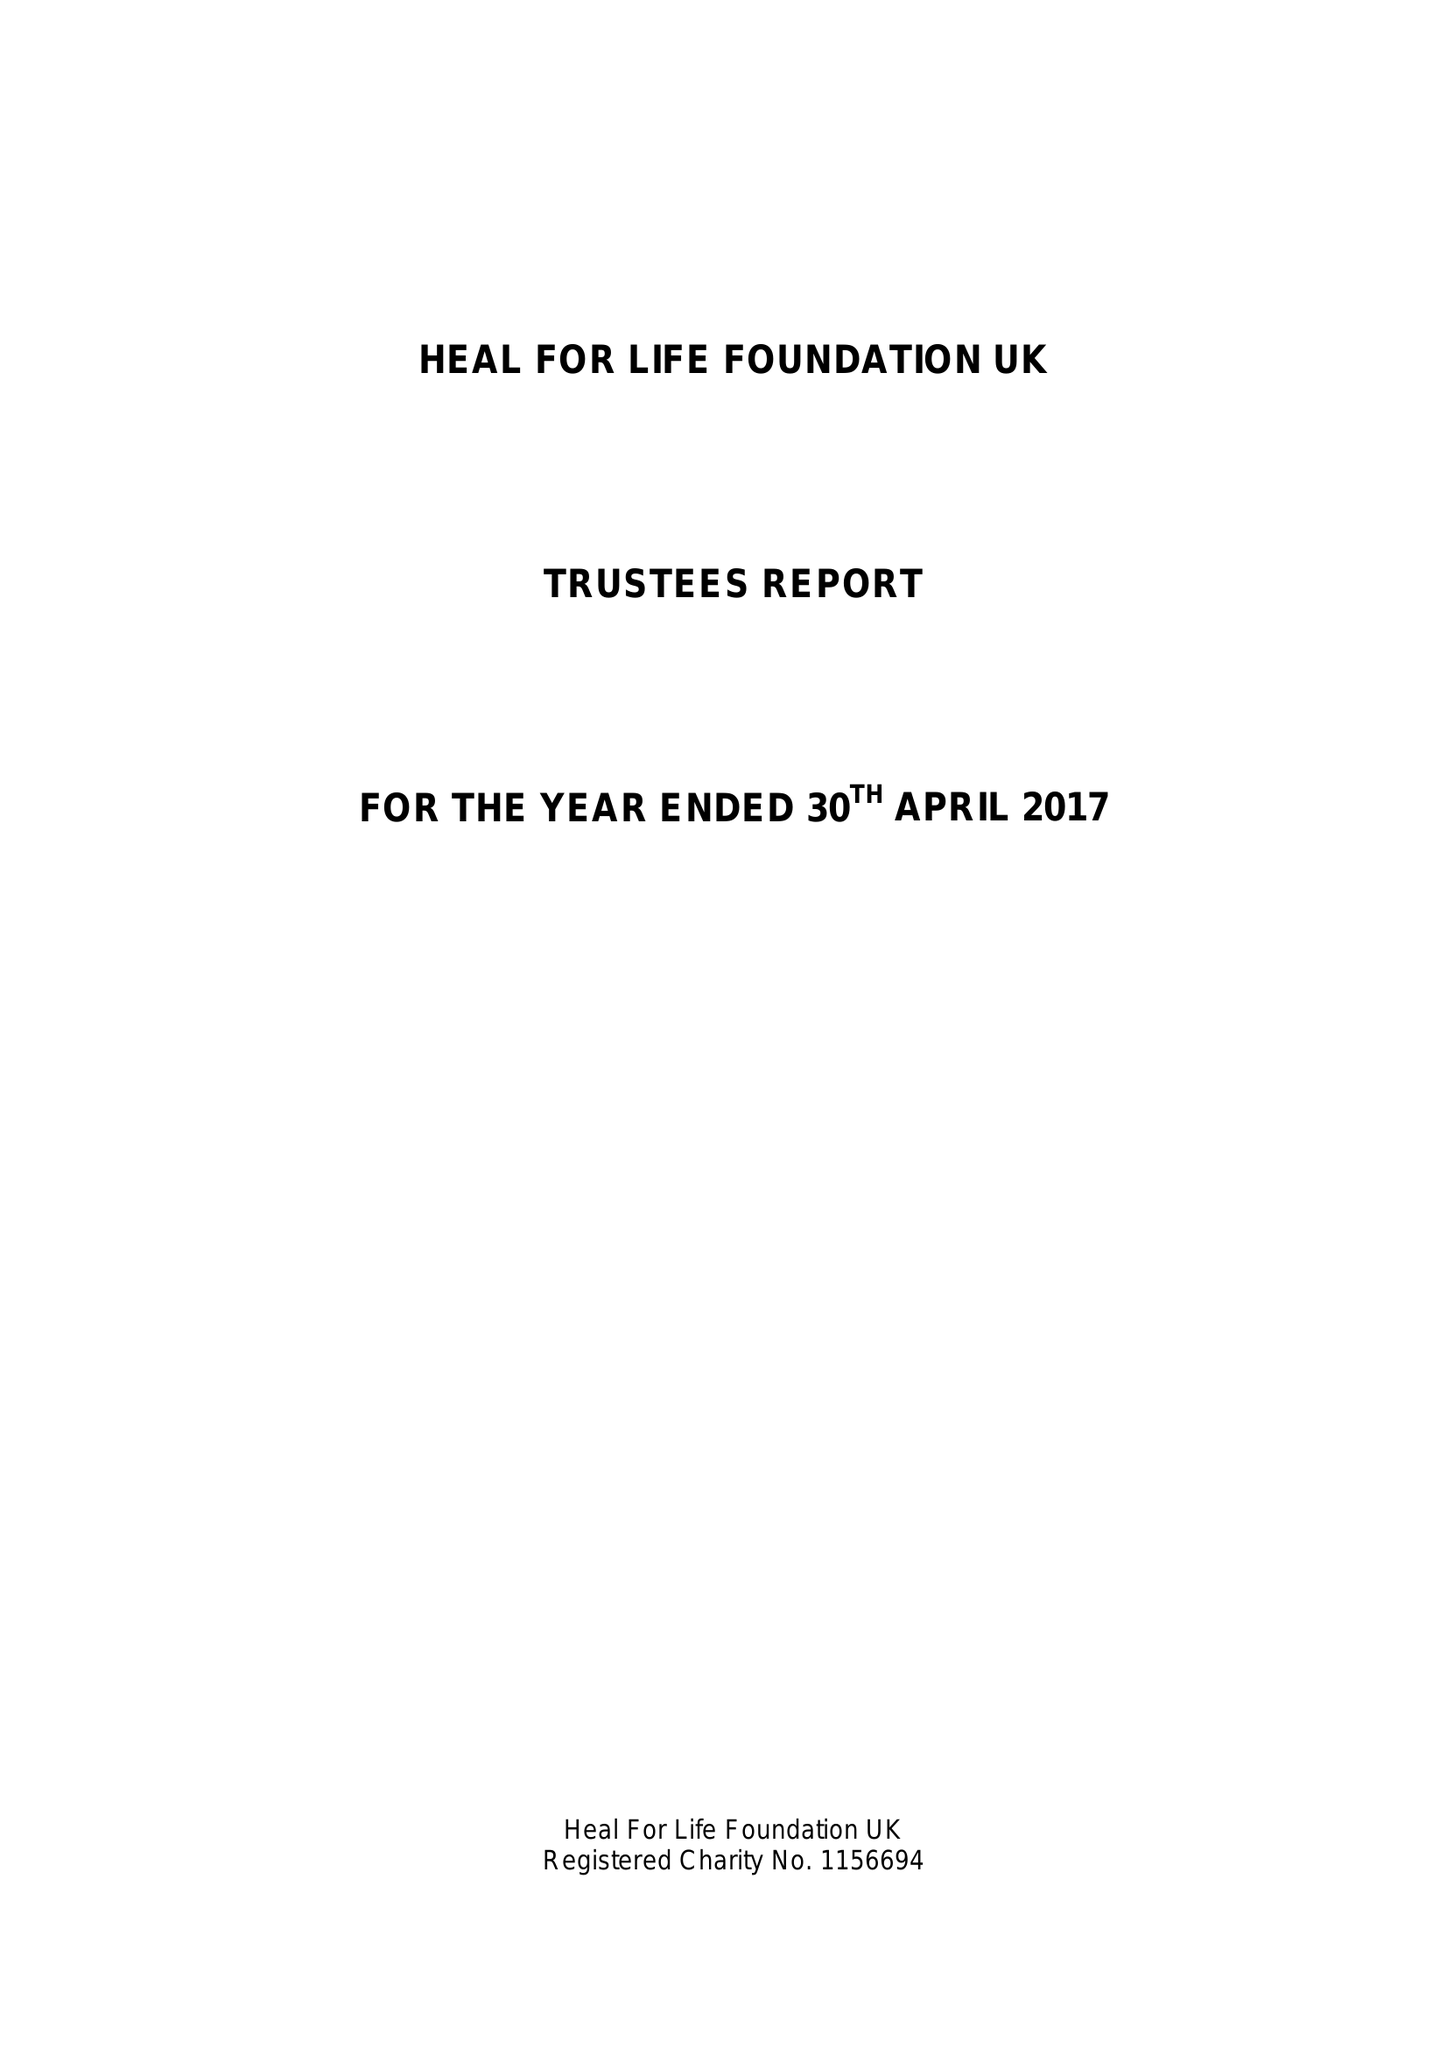What is the value for the address__street_line?
Answer the question using a single word or phrase. 24 CHURCH STREET 